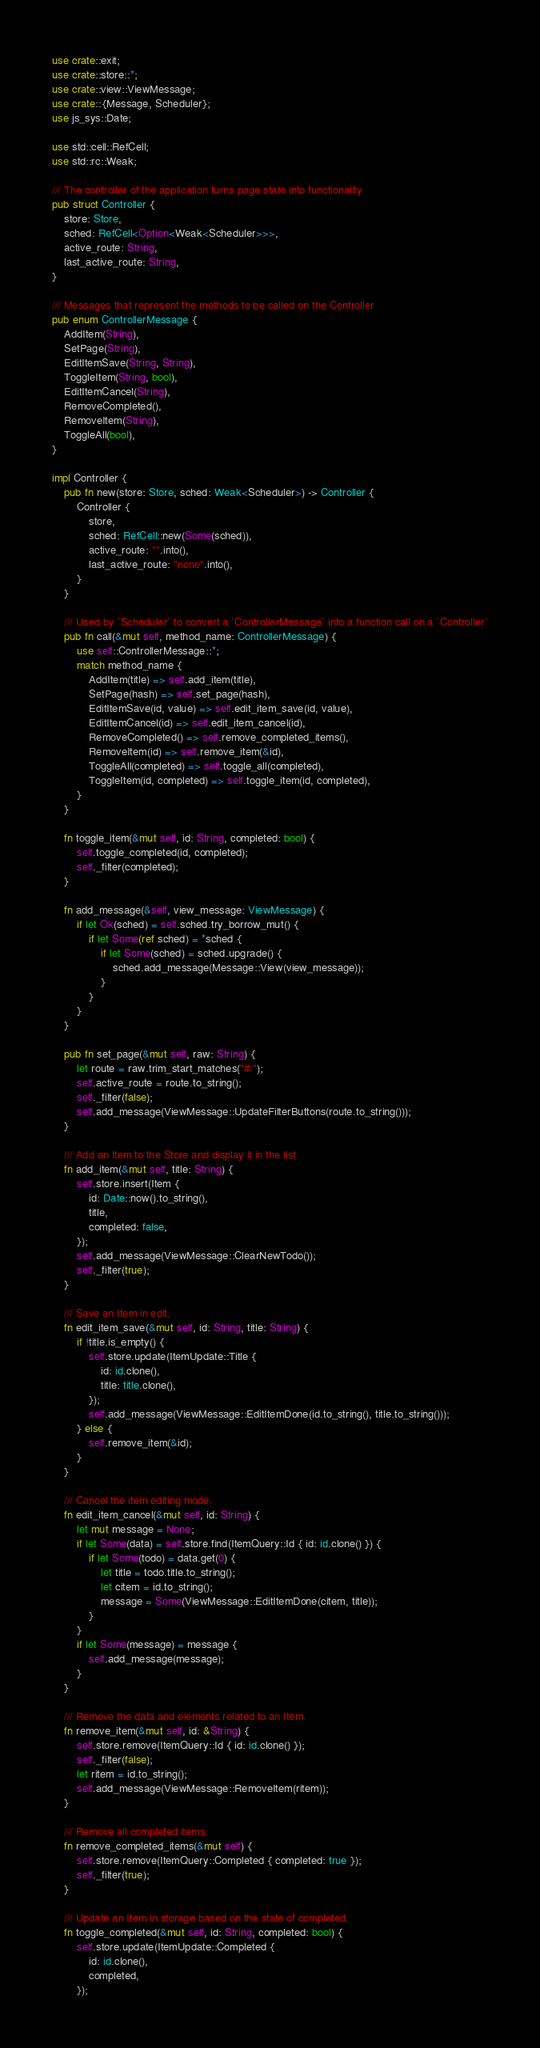<code> <loc_0><loc_0><loc_500><loc_500><_Rust_>use crate::exit;
use crate::store::*;
use crate::view::ViewMessage;
use crate::{Message, Scheduler};
use js_sys::Date;

use std::cell::RefCell;
use std::rc::Weak;

/// The controller of the application turns page state into functionality
pub struct Controller {
    store: Store,
    sched: RefCell<Option<Weak<Scheduler>>>,
    active_route: String,
    last_active_route: String,
}

/// Messages that represent the methods to be called on the Controller
pub enum ControllerMessage {
    AddItem(String),
    SetPage(String),
    EditItemSave(String, String),
    ToggleItem(String, bool),
    EditItemCancel(String),
    RemoveCompleted(),
    RemoveItem(String),
    ToggleAll(bool),
}

impl Controller {
    pub fn new(store: Store, sched: Weak<Scheduler>) -> Controller {
        Controller {
            store,
            sched: RefCell::new(Some(sched)),
            active_route: "".into(),
            last_active_route: "none".into(),
        }
    }

    /// Used by `Scheduler` to convert a `ControllerMessage` into a function call on a `Controller`
    pub fn call(&mut self, method_name: ControllerMessage) {
        use self::ControllerMessage::*;
        match method_name {
            AddItem(title) => self.add_item(title),
            SetPage(hash) => self.set_page(hash),
            EditItemSave(id, value) => self.edit_item_save(id, value),
            EditItemCancel(id) => self.edit_item_cancel(id),
            RemoveCompleted() => self.remove_completed_items(),
            RemoveItem(id) => self.remove_item(&id),
            ToggleAll(completed) => self.toggle_all(completed),
            ToggleItem(id, completed) => self.toggle_item(id, completed),
        }
    }

    fn toggle_item(&mut self, id: String, completed: bool) {
        self.toggle_completed(id, completed);
        self._filter(completed);
    }

    fn add_message(&self, view_message: ViewMessage) {
        if let Ok(sched) = self.sched.try_borrow_mut() {
            if let Some(ref sched) = *sched {
                if let Some(sched) = sched.upgrade() {
                    sched.add_message(Message::View(view_message));
                }
            }
        }
    }

    pub fn set_page(&mut self, raw: String) {
        let route = raw.trim_start_matches("#/");
        self.active_route = route.to_string();
        self._filter(false);
        self.add_message(ViewMessage::UpdateFilterButtons(route.to_string()));
    }

    /// Add an Item to the Store and display it in the list.
    fn add_item(&mut self, title: String) {
        self.store.insert(Item {
            id: Date::now().to_string(),
            title,
            completed: false,
        });
        self.add_message(ViewMessage::ClearNewTodo());
        self._filter(true);
    }

    /// Save an Item in edit.
    fn edit_item_save(&mut self, id: String, title: String) {
        if !title.is_empty() {
            self.store.update(ItemUpdate::Title {
                id: id.clone(),
                title: title.clone(),
            });
            self.add_message(ViewMessage::EditItemDone(id.to_string(), title.to_string()));
        } else {
            self.remove_item(&id);
        }
    }

    /// Cancel the item editing mode.
    fn edit_item_cancel(&mut self, id: String) {
        let mut message = None;
        if let Some(data) = self.store.find(ItemQuery::Id { id: id.clone() }) {
            if let Some(todo) = data.get(0) {
                let title = todo.title.to_string();
                let citem = id.to_string();
                message = Some(ViewMessage::EditItemDone(citem, title));
            }
        }
        if let Some(message) = message {
            self.add_message(message);
        }
    }

    /// Remove the data and elements related to an Item.
    fn remove_item(&mut self, id: &String) {
        self.store.remove(ItemQuery::Id { id: id.clone() });
        self._filter(false);
        let ritem = id.to_string();
        self.add_message(ViewMessage::RemoveItem(ritem));
    }

    /// Remove all completed items.
    fn remove_completed_items(&mut self) {
        self.store.remove(ItemQuery::Completed { completed: true });
        self._filter(true);
    }

    /// Update an Item in storage based on the state of completed.
    fn toggle_completed(&mut self, id: String, completed: bool) {
        self.store.update(ItemUpdate::Completed {
            id: id.clone(),
            completed,
        });</code> 